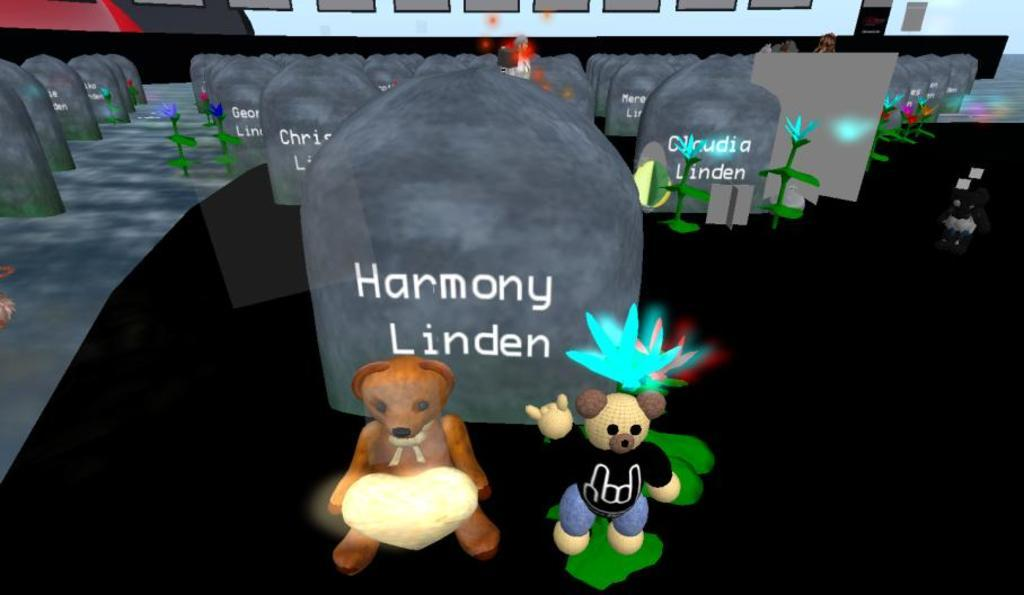What type of drawings or illustrations are present in the image? There are cartoons in the image. What type of material are the plates made of in the image? There are stone plates in the image. What type of vegetation is present in the image? There are plants and flowers in the image. How many times does the character in the cartoon fall down in the image? There is no indication of the character falling down in the image, as it only shows cartoons, stone plates, plants, and flowers. What type of wall is present in the image? There is no wall present in the image; it features cartoons, stone plates, plants, and flowers. 